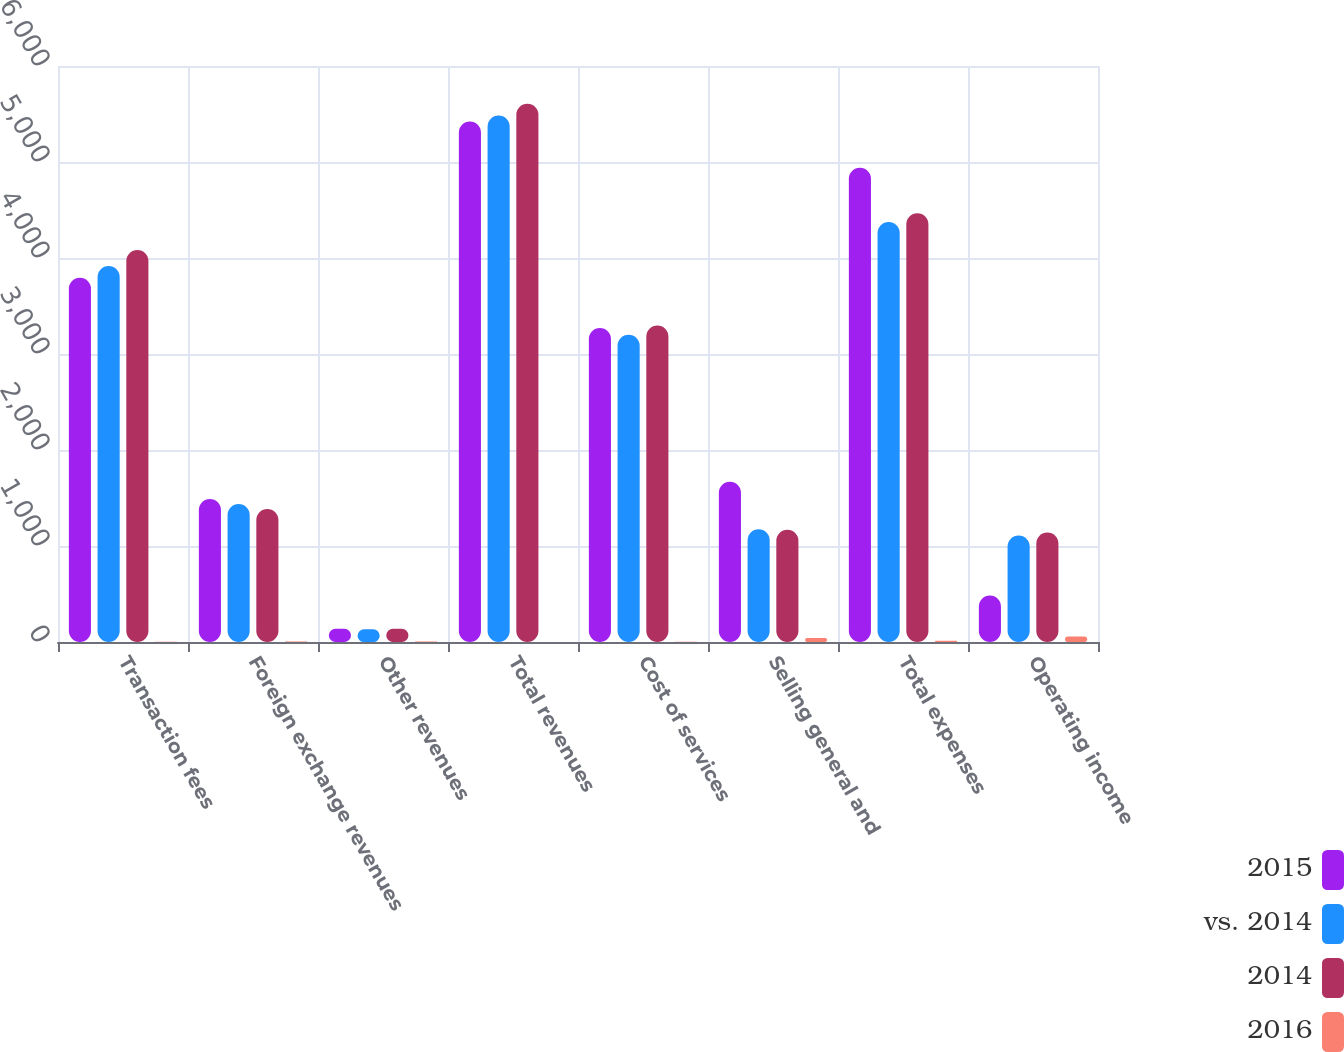Convert chart. <chart><loc_0><loc_0><loc_500><loc_500><stacked_bar_chart><ecel><fcel>Transaction fees<fcel>Foreign exchange revenues<fcel>Other revenues<fcel>Total revenues<fcel>Cost of services<fcel>Selling general and<fcel>Total expenses<fcel>Operating income<nl><fcel>2015<fcel>3795.1<fcel>1490.2<fcel>137.6<fcel>5422.9<fcel>3270<fcel>1669.2<fcel>4939.2<fcel>483.7<nl><fcel>vs. 2014<fcel>3915.6<fcel>1436.2<fcel>131.9<fcel>5483.7<fcel>3199.4<fcel>1174.9<fcel>4374.3<fcel>1109.4<nl><fcel>2014<fcel>4083.6<fcel>1386.3<fcel>137.3<fcel>5607.2<fcel>3297.4<fcel>1169.3<fcel>4466.7<fcel>1140.5<nl><fcel>2016<fcel>3<fcel>4<fcel>4<fcel>1<fcel>2<fcel>42<fcel>13<fcel>56<nl></chart> 